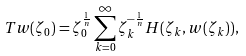Convert formula to latex. <formula><loc_0><loc_0><loc_500><loc_500>T w ( \zeta _ { 0 } ) = \zeta _ { 0 } ^ { \frac { 1 } { n } } \sum _ { k = 0 } ^ { \infty } \zeta _ { k } ^ { - \frac { 1 } { n } } H ( \zeta _ { k } , w ( \zeta _ { k } ) ) ,</formula> 